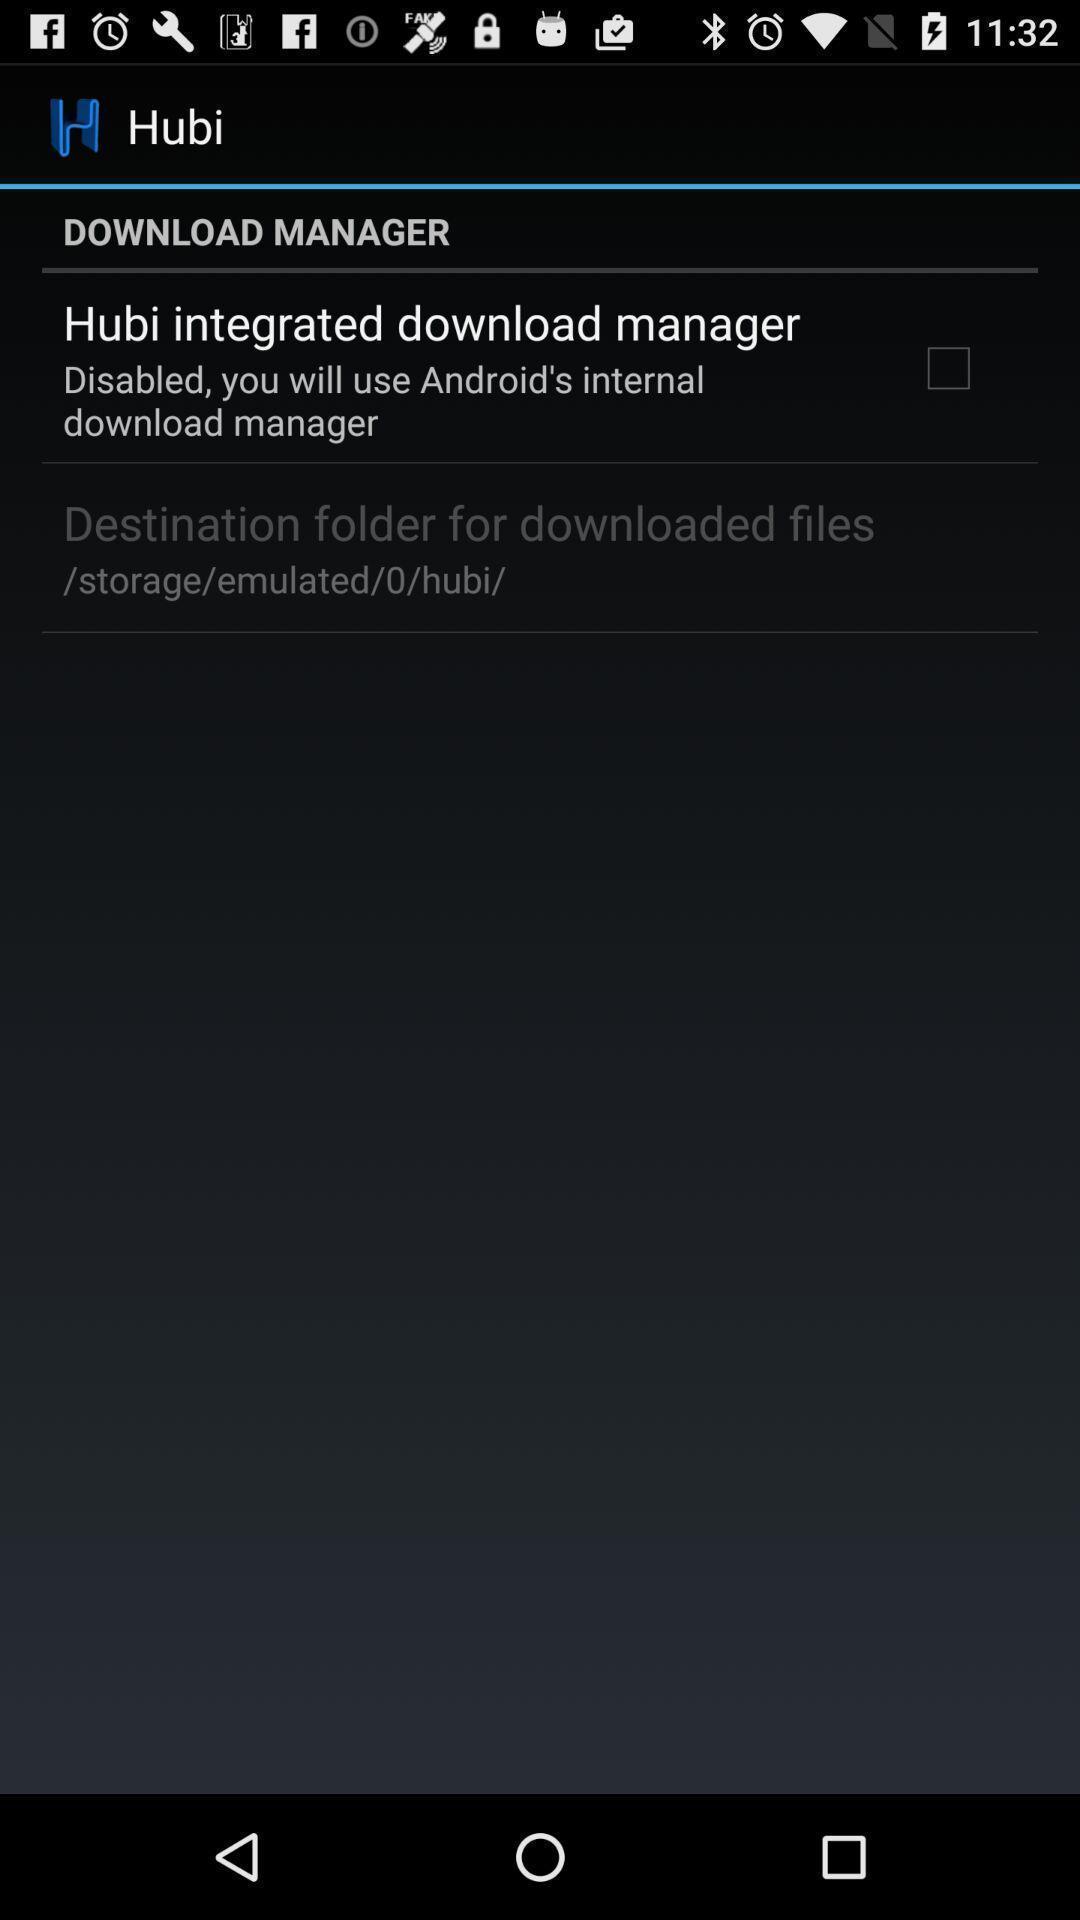Please provide a description for this image. Page showing the options. 